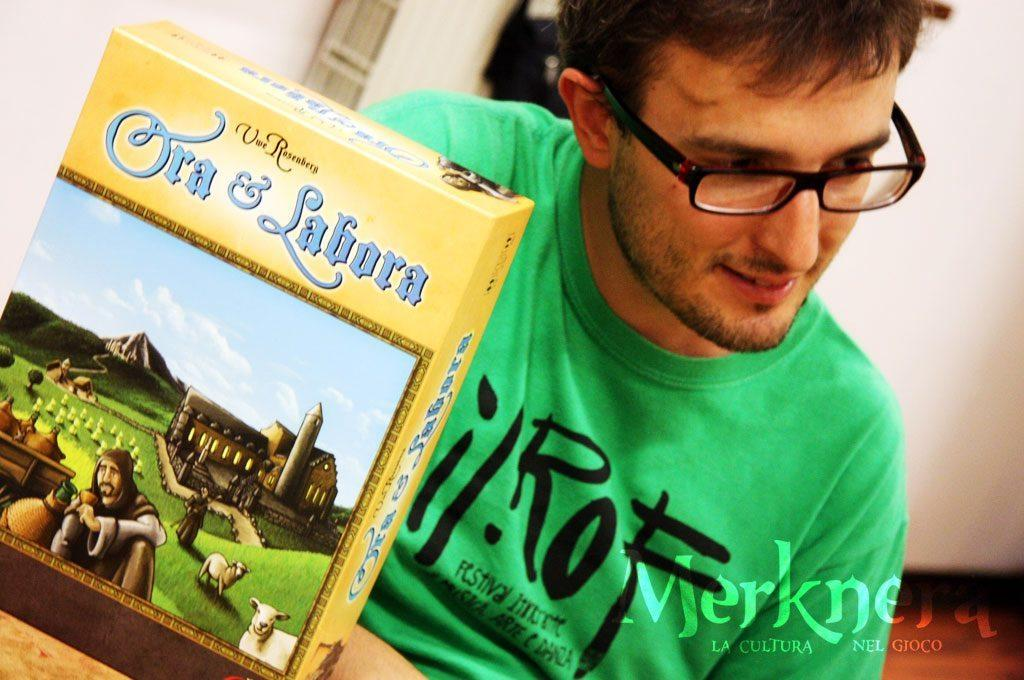Who is present in the image? There is a man in the image. What is the man wearing? The man is wearing a green shirt. What can be seen in the background of the image? There is a wall in the background of the image. What object is placed on a table in the image? There is a carton placed on a table in the image. What type of flowers can be seen growing on the grass in the image? There is no grass or flowers present in the image. 